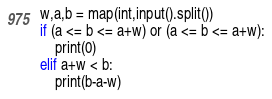Convert code to text. <code><loc_0><loc_0><loc_500><loc_500><_Python_>w,a,b = map(int,input().split())
if (a <= b <= a+w) or (a <= b <= a+w):
    print(0)
elif a+w < b:
    print(b-a-w)</code> 